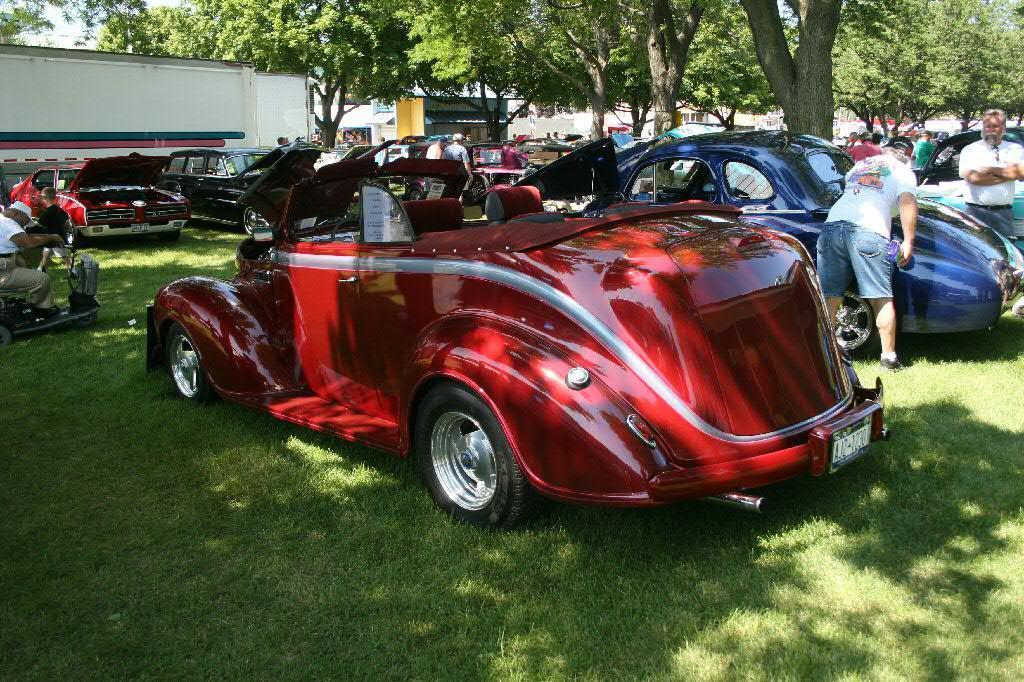What types of man-made structures can be seen in the image? There are buildings in the image. What natural elements are present in the image? There are trees and grass in the image. What is the primary feature of the land in the image? The land is covered with grass. What types of vehicles can be seen in the image? There are vehicles in the image. What are the people in the image doing? There are people in the image, and some of them are holding objects. What other objects can be seen in the image? There are objects in the image. What type of bells can be heard ringing in the image? There are no bells present in the image, and therefore no sound can be heard. What year does the image depict? The image does not provide any information about the year it represents. 